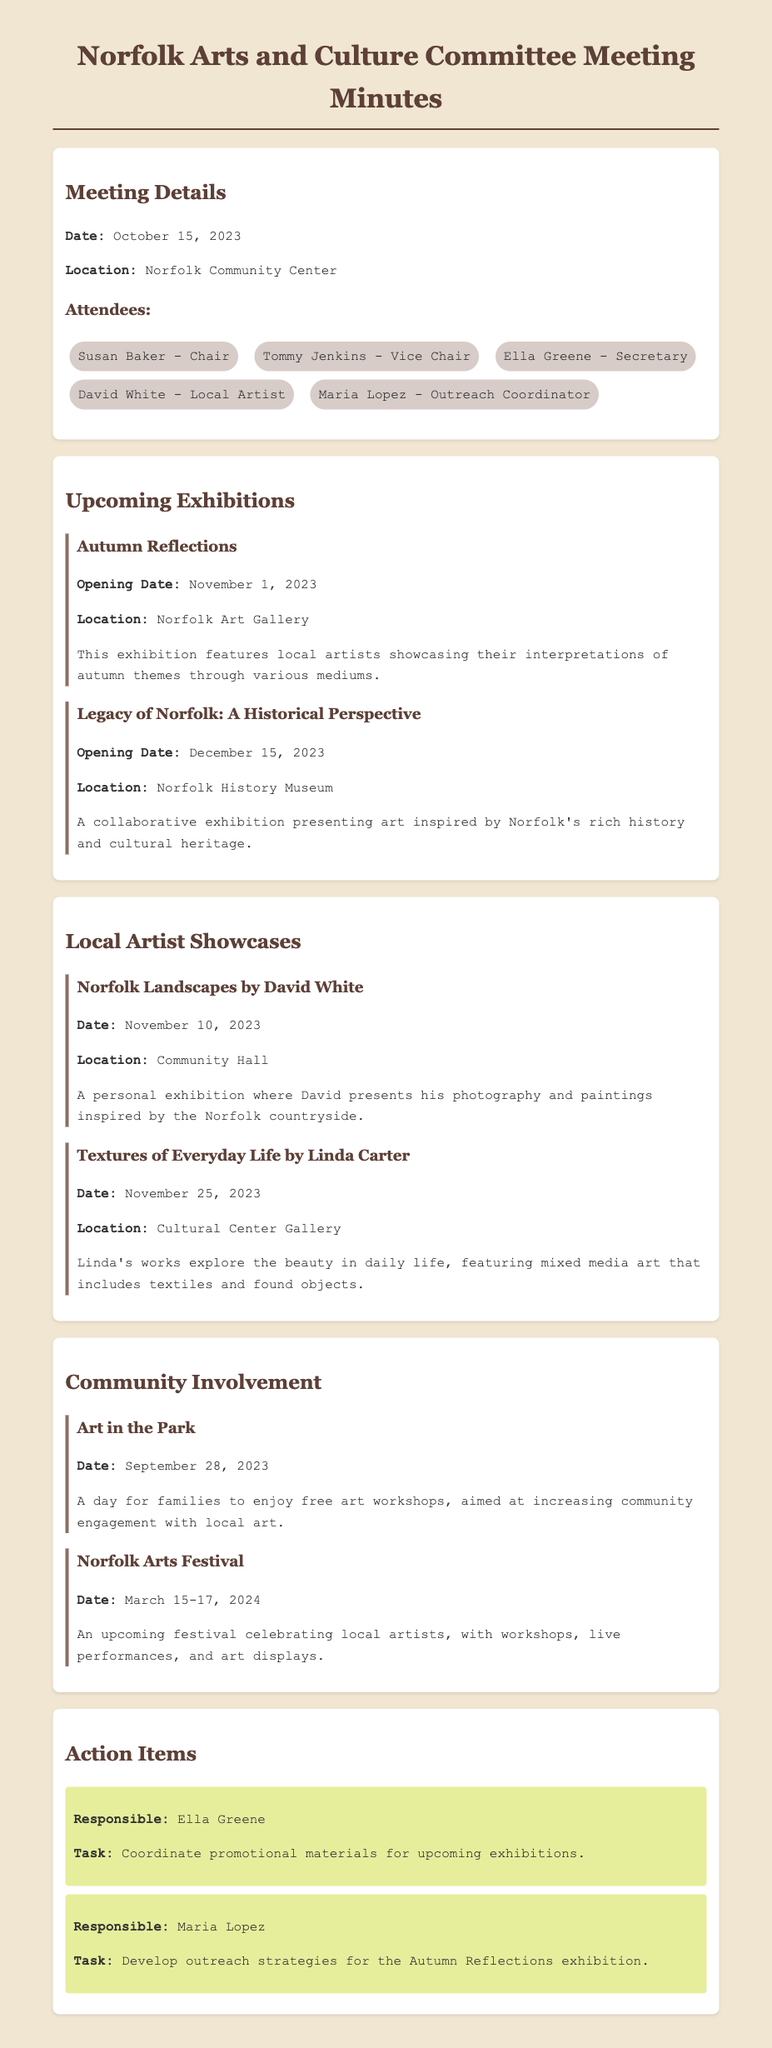What is the opening date of the Autumn Reflections exhibition? The opening date for the Autumn Reflections exhibition is specified in the document.
Answer: November 1, 2023 Where is the Norfolk Landscapes showcase being held? The location of the Norfolk Landscapes showcase is mentioned in the document.
Answer: Community Hall What is the title of the exhibition that focuses on Norfolk's history? The title of the exhibition focusing on Norfolk's history is present in the document's exhibitions section.
Answer: Legacy of Norfolk: A Historical Perspective Who is responsible for coordinating promotional materials for upcoming exhibitions? The document lists action items along with the responsible persons.
Answer: Ella Greene When is the Norfolk Arts Festival scheduled? The date for the Norfolk Arts Festival is provided in the document under community events.
Answer: March 15-17, 2024 What type of art does Linda Carter's showcase focus on? The document describes the type of work Linda Carter will showcase, which includes specific elements.
Answer: Mixed media art What event took place on September 28, 2023? The document details various community involvement programs, including specific dates for each.
Answer: Art in the Park How many exhibitions are mentioned in the document? The total count of exhibitions listed in the document can be derived from the respective section.
Answer: Two 